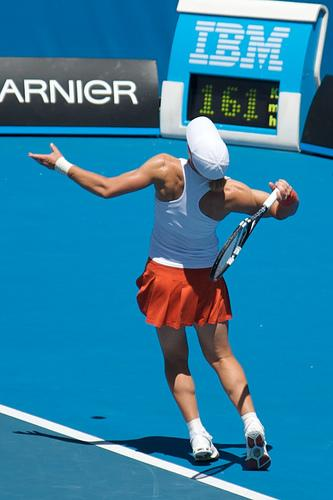What is the person doing?

Choices:
A) returning
B) star gazing
C) sun spotting
D) serving serving 